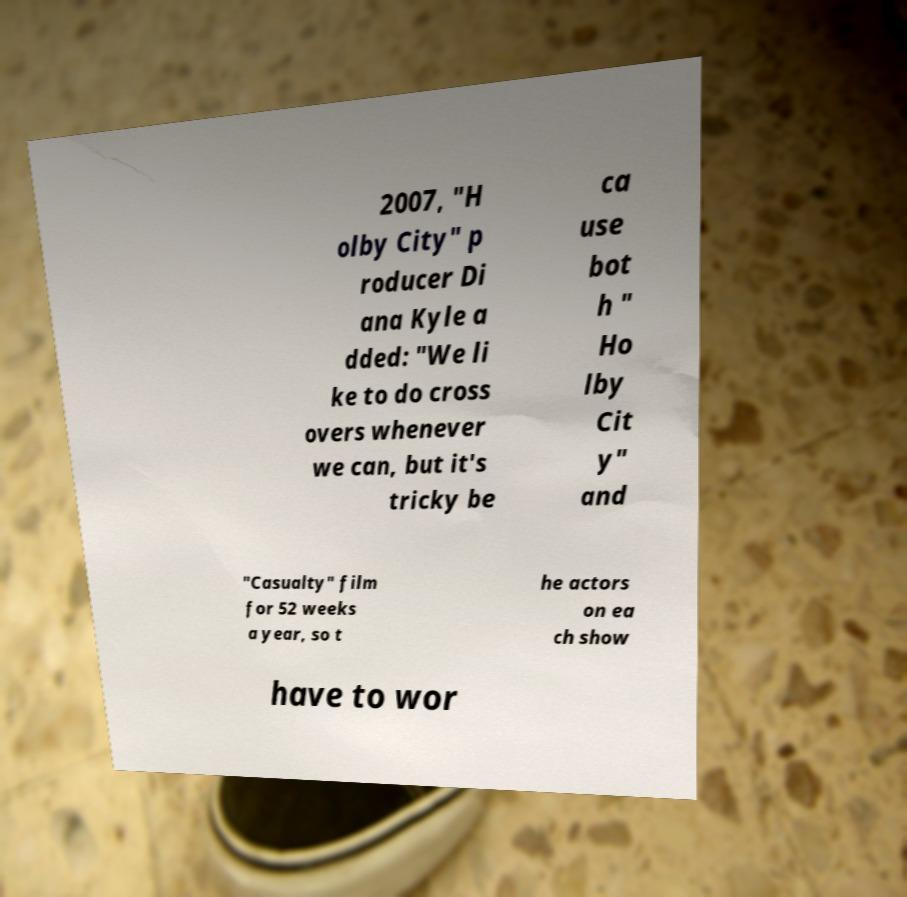Could you extract and type out the text from this image? 2007, "H olby City" p roducer Di ana Kyle a dded: "We li ke to do cross overs whenever we can, but it's tricky be ca use bot h " Ho lby Cit y" and "Casualty" film for 52 weeks a year, so t he actors on ea ch show have to wor 